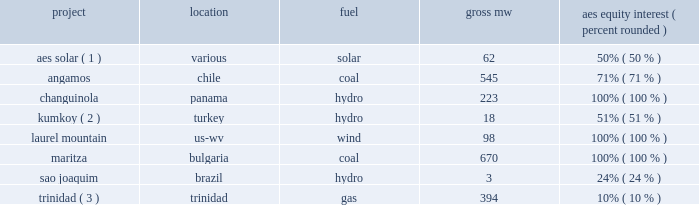Management 2019s priorities management has re-evaluated its priorities following the appointment of its new ceo in september 2011 .
Management is focused on the following priorities : 2022 execution of our geographic concentration strategy to maximize shareholder value through disciplined capital allocation including : 2022 platform expansion in brazil , chile , colombia , and the united states , 2022 platform development in turkey , poland , and the united kingdom , 2022 corporate debt reduction , and 2022 a return of capital to shareholders , including our intent to initiate a dividend in 2012 ; 2022 closing the sales of businesses for which we have signed agreements with counterparties and prudently exiting select non-strategic markets ; 2022 optimizing profitability of operations in the existing portfolio ; 2022 integration of dpl into our portfolio ; 2022 implementing a management realignment of our businesses under two business lines : utilities and generation , and achieving cost savings through the alignment of overhead costs with business requirements , systems automation and optimal allocation of business development spending ; and 2022 completion of an approximately 2400 mw construction program and the integration of new projects into existing businesses .
During the year ended december 31 , 2011 , the following projects commenced commercial operations : project location fuel aes equity interest ( percent , rounded ) aes solar ( 1 ) .
Various solar 62 50% ( 50 % ) .
Trinidad ( 3 ) .
Trinidad gas 394 10% ( 10 % ) ( 1 ) aes solar energy ltd .
Is a joint venture with riverstone holdings and is accounted for as an equity method investment .
Plants that came online during the year include : kalipetrovo , ugento , soemina , francavilla fontana , latina , cocomeri , francofonte , scopeto , sabaudia , aprilla-1 , siracusa 1-3 complex , manduria apollo and rinaldone .
( 2 ) joint venture with i.c .
Energy .
( 3 ) an equity method investment held by aes .
Key trends and uncertainties our operations continue to face many risks as discussed in item 1a . 2014risk factors of this form 10-k .
Some of these challenges are also described below in 201ckey drivers of results in 2011 201d .
We continue to monitor our operations and address challenges as they arise .
Operations in august 2010 , the esti power plant , a 120 mw run-of-river hydroelectric power plant in panama , was taken offline due to damage to its tunnel infrastructure .
Aes panama is partially covered for business .
In gross mw , what is the company's total coal capacity? 
Computations: (670 + 545)
Answer: 1215.0. 